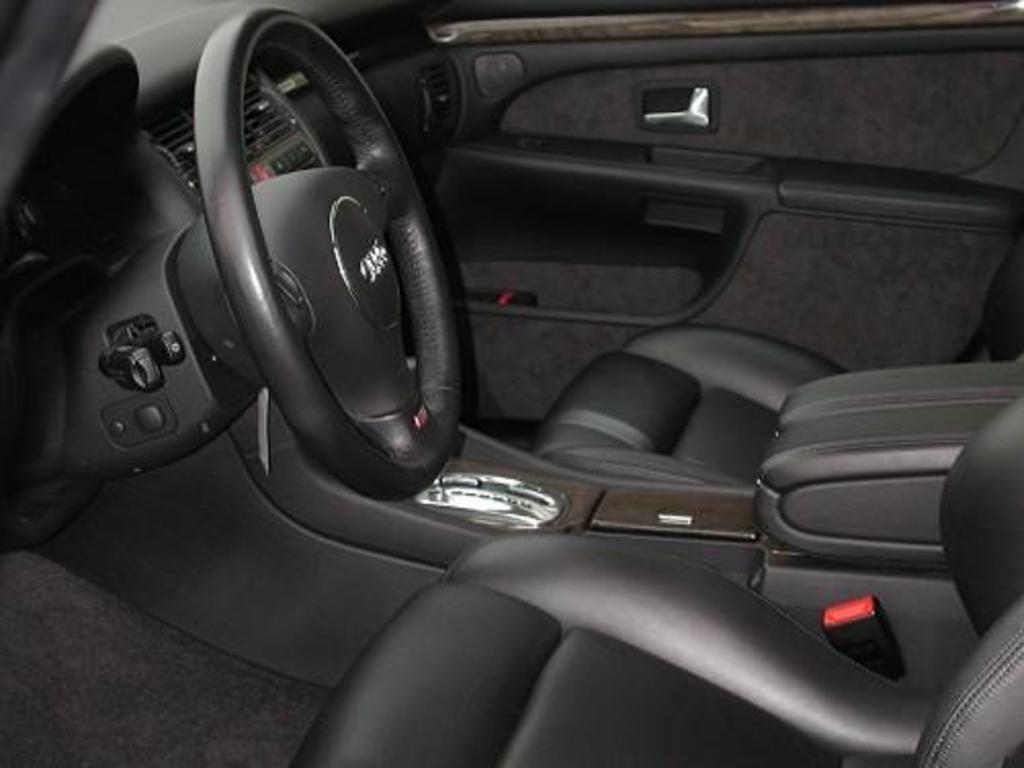Describe this image in one or two sentences. This image is a inside picture of a car. There is a steering, seats. 